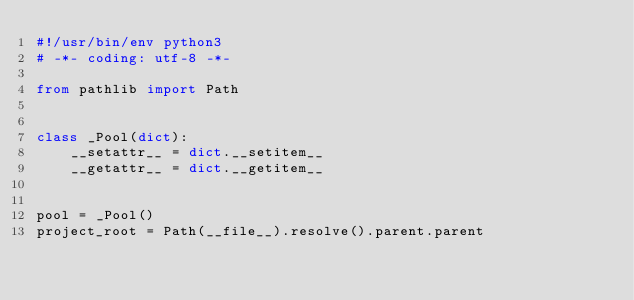Convert code to text. <code><loc_0><loc_0><loc_500><loc_500><_Python_>#!/usr/bin/env python3
# -*- coding: utf-8 -*-

from pathlib import Path


class _Pool(dict):
    __setattr__ = dict.__setitem__
    __getattr__ = dict.__getitem__


pool = _Pool()
project_root = Path(__file__).resolve().parent.parent
</code> 